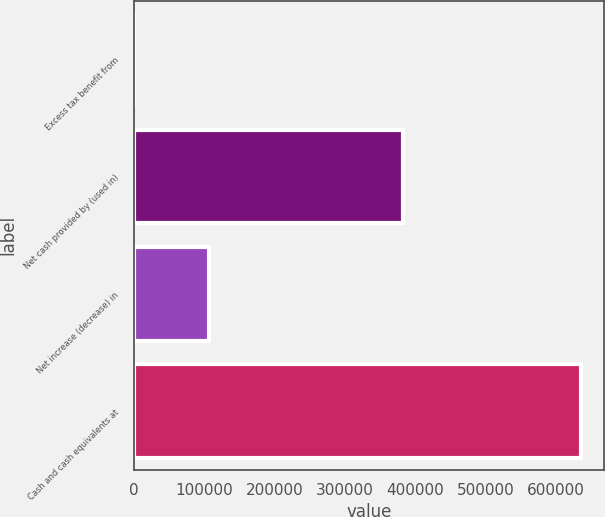Convert chart to OTSL. <chart><loc_0><loc_0><loc_500><loc_500><bar_chart><fcel>Excess tax benefit from<fcel>Net cash provided by (used in)<fcel>Net increase (decrease) in<fcel>Cash and cash equivalents at<nl><fcel>297<fcel>382170<fcel>107421<fcel>635755<nl></chart> 